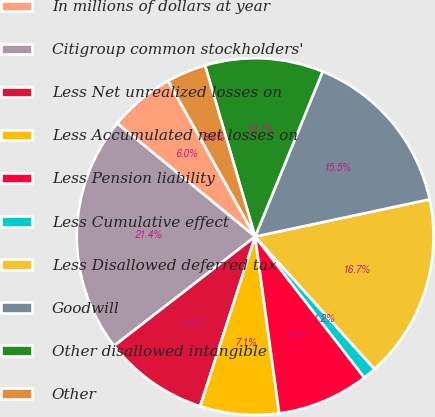Convert chart to OTSL. <chart><loc_0><loc_0><loc_500><loc_500><pie_chart><fcel>In millions of dollars at year<fcel>Citigroup common stockholders'<fcel>Less Net unrealized losses on<fcel>Less Accumulated net losses on<fcel>Less Pension liability<fcel>Less Cumulative effect<fcel>Less Disallowed deferred tax<fcel>Goodwill<fcel>Other disallowed intangible<fcel>Other<nl><fcel>5.95%<fcel>21.42%<fcel>9.52%<fcel>7.14%<fcel>8.33%<fcel>1.19%<fcel>16.66%<fcel>15.47%<fcel>10.71%<fcel>3.57%<nl></chart> 